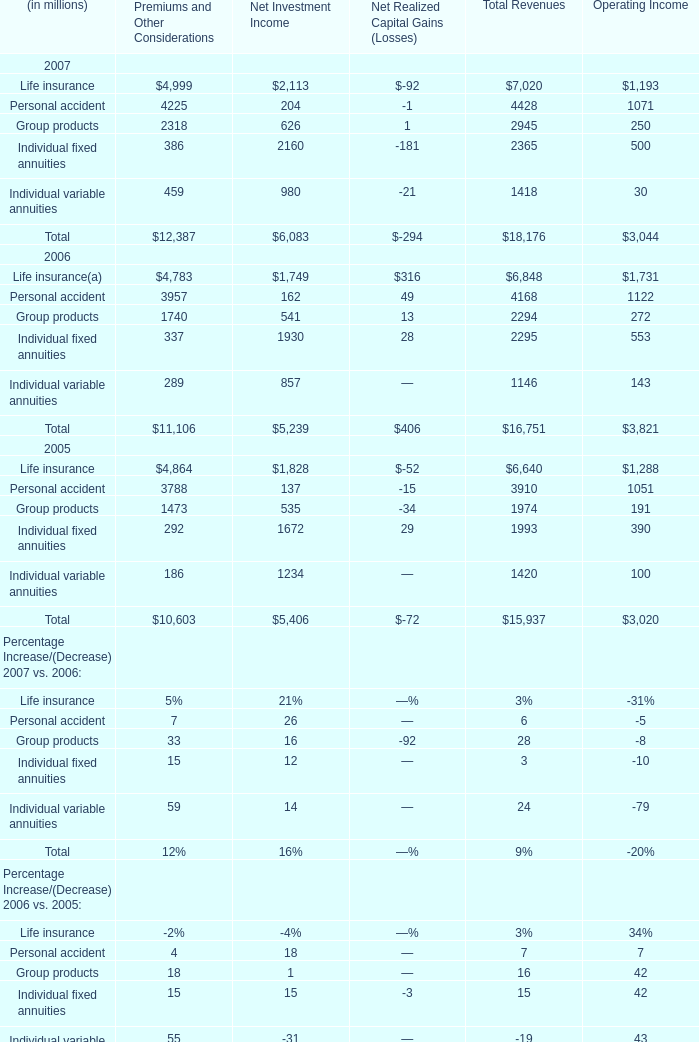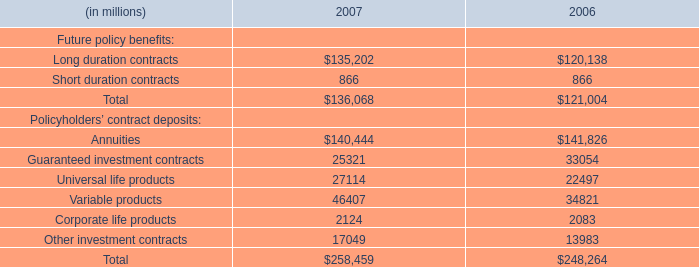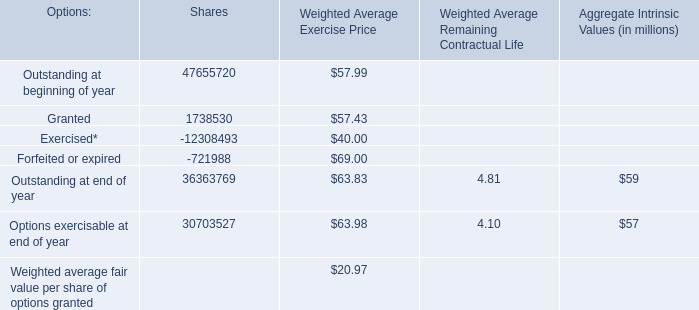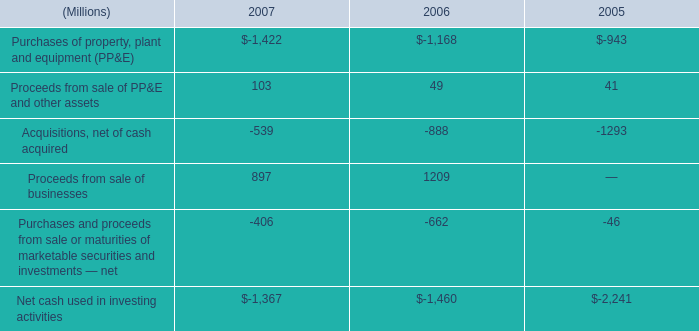What's the sum of Premiums and Other Considerations in 2007? (in million) 
Answer: 12387. 